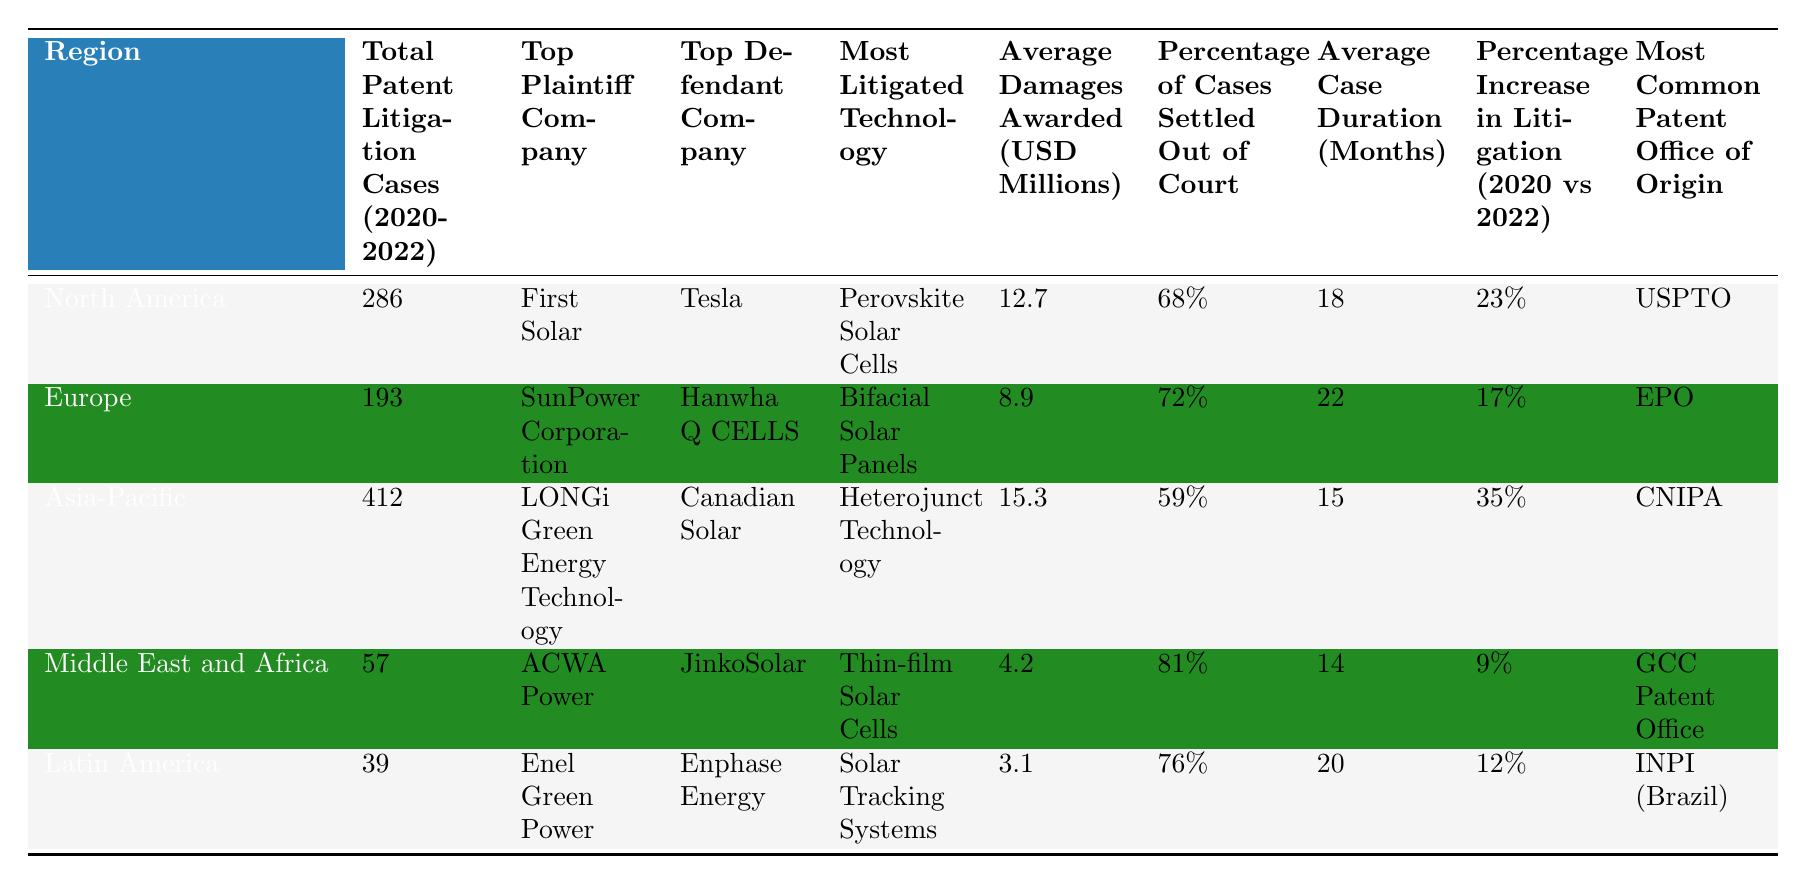What is the total number of patent litigation cases in Asia-Pacific from 2020 to 2022? The table shows that the total number of patent litigation cases in Asia-Pacific is 412.
Answer: 412 Which company was the top plaintiff in North America? According to the table, the top plaintiff company in North America is First Solar.
Answer: First Solar What is the average damages awarded for patent litigation cases in Europe? The table indicates that the average damages awarded in Europe is 8.9 million USD.
Answer: 8.9 million USD What percentage of cases were settled out of court in the Middle East and Africa? The table lists that 81% of cases were settled out of court in the Middle East and Africa.
Answer: 81% Which region has the highest percentage increase in litigation cases from 2020 to 2022? The table shows that Asia-Pacific has the highest percentage increase in litigation cases at 35%.
Answer: Asia-Pacific How does the average case duration in Latin America compare to the average case duration in North America? The average case duration in Latin America is 20 months, while in North America it is 18 months; Latin America has a longer duration by 2 months.
Answer: 2 months longer Is there a greater average damages awarded in the Asia-Pacific region compared to the Europe region? The table lists the average damages awarded in Asia-Pacific as 15.3 million USD and in Europe as 8.9 million USD; thus, Asia-Pacific has a higher average.
Answer: Yes What is the most litigated technology in the region with the lowest total patent litigation cases? The region with the lowest total cases is Latin America (39 cases), and the most litigated technology there is Solar Tracking Systems.
Answer: Solar Tracking Systems Calculate the average percentage of cases settled out of court across all regions. The percentages are 68%, 72%, 59%, 81%, and 76%. Adding these values gives 356, and dividing by 5 yields an average of 71.2%.
Answer: 71.2% Which region has the lowest average damages awarded? The table shows that Latin America has the lowest average damages awarded at 3.1 million USD.
Answer: Latin America Is the top plaintiff in Europe the same as the top plaintiff in North America? The top plaintiff in Europe is SunPower Corporation, while in North America it is First Solar; thus, they are not the same.
Answer: No 